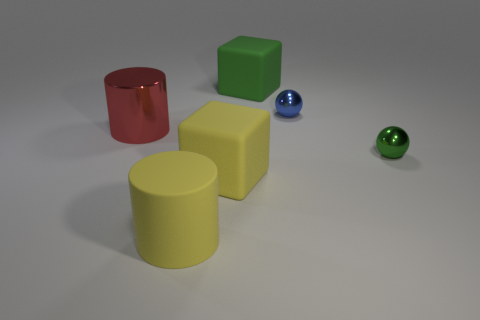Subtract 1 cylinders. How many cylinders are left? 1 Add 1 shiny cylinders. How many objects exist? 7 Subtract all spheres. How many objects are left? 4 Subtract all red cylinders. How many cylinders are left? 1 Subtract 1 green spheres. How many objects are left? 5 Subtract all red cylinders. Subtract all purple cubes. How many cylinders are left? 1 Subtract all yellow blocks. How many yellow cylinders are left? 1 Subtract all large blue matte cylinders. Subtract all yellow cylinders. How many objects are left? 5 Add 6 big cylinders. How many big cylinders are left? 8 Add 3 large matte things. How many large matte things exist? 6 